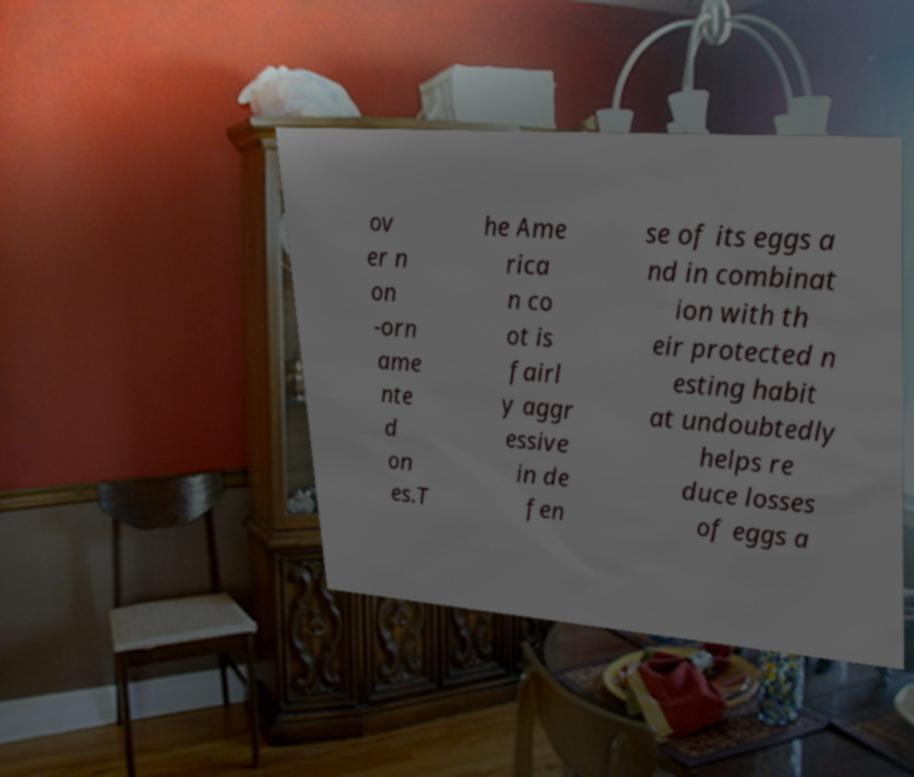Can you accurately transcribe the text from the provided image for me? ov er n on -orn ame nte d on es.T he Ame rica n co ot is fairl y aggr essive in de fen se of its eggs a nd in combinat ion with th eir protected n esting habit at undoubtedly helps re duce losses of eggs a 